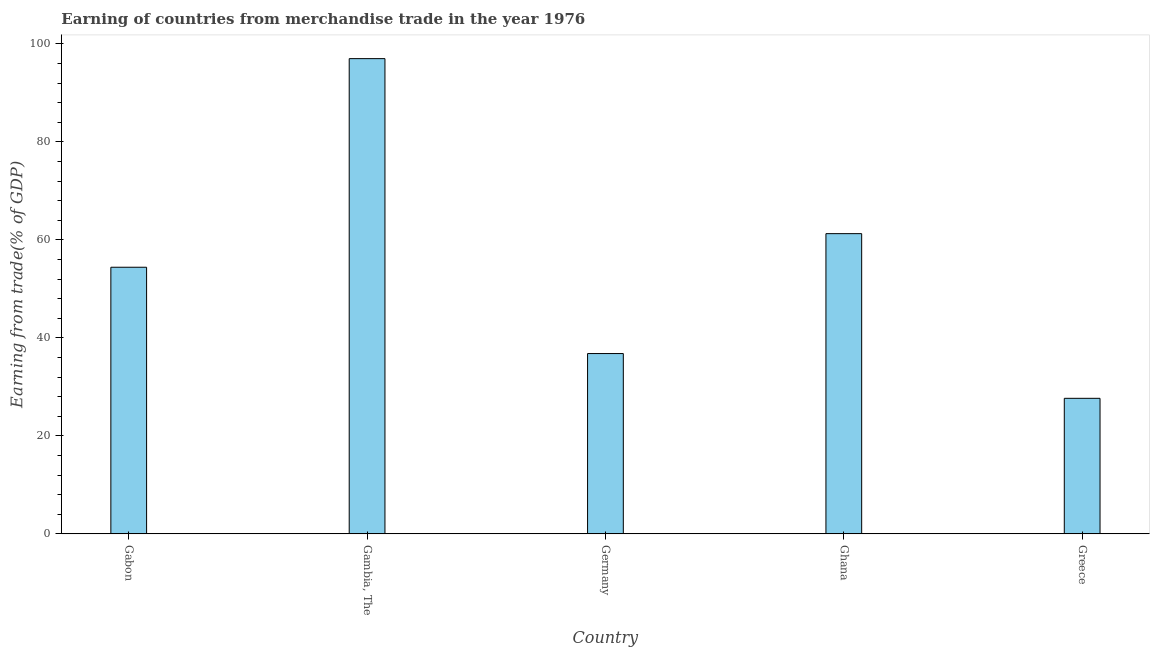Does the graph contain any zero values?
Provide a succinct answer. No. What is the title of the graph?
Your answer should be very brief. Earning of countries from merchandise trade in the year 1976. What is the label or title of the Y-axis?
Give a very brief answer. Earning from trade(% of GDP). What is the earning from merchandise trade in Greece?
Make the answer very short. 27.67. Across all countries, what is the maximum earning from merchandise trade?
Provide a succinct answer. 97.01. Across all countries, what is the minimum earning from merchandise trade?
Provide a succinct answer. 27.67. In which country was the earning from merchandise trade maximum?
Make the answer very short. Gambia, The. What is the sum of the earning from merchandise trade?
Keep it short and to the point. 277.2. What is the difference between the earning from merchandise trade in Gabon and Gambia, The?
Provide a succinct answer. -42.58. What is the average earning from merchandise trade per country?
Keep it short and to the point. 55.44. What is the median earning from merchandise trade?
Offer a very short reply. 54.43. What is the ratio of the earning from merchandise trade in Gabon to that in Gambia, The?
Offer a very short reply. 0.56. Is the earning from merchandise trade in Gambia, The less than that in Germany?
Offer a terse response. No. What is the difference between the highest and the second highest earning from merchandise trade?
Offer a very short reply. 35.72. Is the sum of the earning from merchandise trade in Germany and Greece greater than the maximum earning from merchandise trade across all countries?
Give a very brief answer. No. What is the difference between the highest and the lowest earning from merchandise trade?
Provide a short and direct response. 69.34. How many bars are there?
Keep it short and to the point. 5. How many countries are there in the graph?
Offer a terse response. 5. What is the difference between two consecutive major ticks on the Y-axis?
Your response must be concise. 20. What is the Earning from trade(% of GDP) in Gabon?
Offer a very short reply. 54.43. What is the Earning from trade(% of GDP) of Gambia, The?
Your answer should be very brief. 97.01. What is the Earning from trade(% of GDP) in Germany?
Give a very brief answer. 36.81. What is the Earning from trade(% of GDP) of Ghana?
Keep it short and to the point. 61.29. What is the Earning from trade(% of GDP) in Greece?
Your answer should be very brief. 27.67. What is the difference between the Earning from trade(% of GDP) in Gabon and Gambia, The?
Your answer should be compact. -42.58. What is the difference between the Earning from trade(% of GDP) in Gabon and Germany?
Your answer should be compact. 17.62. What is the difference between the Earning from trade(% of GDP) in Gabon and Ghana?
Keep it short and to the point. -6.86. What is the difference between the Earning from trade(% of GDP) in Gabon and Greece?
Provide a short and direct response. 26.76. What is the difference between the Earning from trade(% of GDP) in Gambia, The and Germany?
Your response must be concise. 60.2. What is the difference between the Earning from trade(% of GDP) in Gambia, The and Ghana?
Ensure brevity in your answer.  35.72. What is the difference between the Earning from trade(% of GDP) in Gambia, The and Greece?
Offer a very short reply. 69.34. What is the difference between the Earning from trade(% of GDP) in Germany and Ghana?
Give a very brief answer. -24.48. What is the difference between the Earning from trade(% of GDP) in Germany and Greece?
Provide a succinct answer. 9.14. What is the difference between the Earning from trade(% of GDP) in Ghana and Greece?
Your response must be concise. 33.62. What is the ratio of the Earning from trade(% of GDP) in Gabon to that in Gambia, The?
Offer a very short reply. 0.56. What is the ratio of the Earning from trade(% of GDP) in Gabon to that in Germany?
Give a very brief answer. 1.48. What is the ratio of the Earning from trade(% of GDP) in Gabon to that in Ghana?
Provide a succinct answer. 0.89. What is the ratio of the Earning from trade(% of GDP) in Gabon to that in Greece?
Offer a terse response. 1.97. What is the ratio of the Earning from trade(% of GDP) in Gambia, The to that in Germany?
Your answer should be very brief. 2.64. What is the ratio of the Earning from trade(% of GDP) in Gambia, The to that in Ghana?
Keep it short and to the point. 1.58. What is the ratio of the Earning from trade(% of GDP) in Gambia, The to that in Greece?
Your answer should be very brief. 3.51. What is the ratio of the Earning from trade(% of GDP) in Germany to that in Ghana?
Provide a short and direct response. 0.6. What is the ratio of the Earning from trade(% of GDP) in Germany to that in Greece?
Provide a succinct answer. 1.33. What is the ratio of the Earning from trade(% of GDP) in Ghana to that in Greece?
Provide a succinct answer. 2.21. 